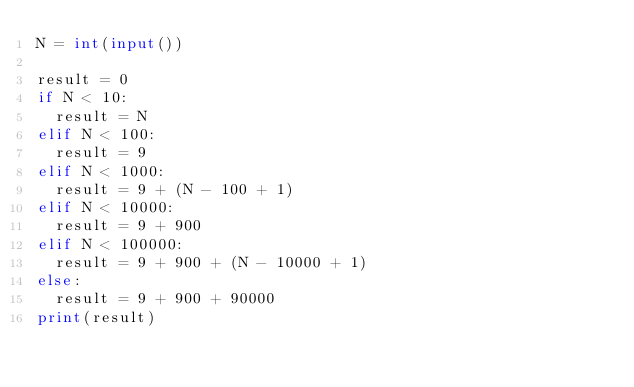<code> <loc_0><loc_0><loc_500><loc_500><_Python_>N = int(input())

result = 0
if N < 10:
  result = N
elif N < 100:
  result = 9
elif N < 1000:
  result = 9 + (N - 100 + 1)
elif N < 10000:
  result = 9 + 900
elif N < 100000:
  result = 9 + 900 + (N - 10000 + 1)
else:
  result = 9 + 900 + 90000
print(result)</code> 